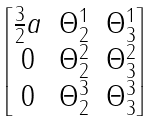<formula> <loc_0><loc_0><loc_500><loc_500>\begin{bmatrix} \frac { 3 } { 2 } a & \Theta ^ { 1 } _ { 2 } & \Theta ^ { 1 } _ { 3 } \\ 0 & \Theta ^ { 2 } _ { 2 } & \Theta ^ { 2 } _ { 3 } \\ 0 & \Theta ^ { 3 } _ { 2 } & \Theta ^ { 3 } _ { 3 } \end{bmatrix}</formula> 